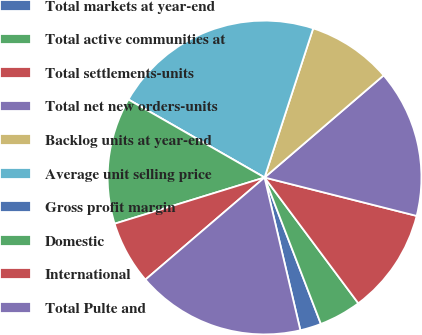<chart> <loc_0><loc_0><loc_500><loc_500><pie_chart><fcel>Total markets at year-end<fcel>Total active communities at<fcel>Total settlements-units<fcel>Total net new orders-units<fcel>Backlog units at year-end<fcel>Average unit selling price<fcel>Gross profit margin<fcel>Domestic<fcel>International<fcel>Total Pulte and<nl><fcel>2.18%<fcel>4.35%<fcel>10.87%<fcel>15.22%<fcel>8.7%<fcel>21.74%<fcel>0.0%<fcel>13.04%<fcel>6.52%<fcel>17.39%<nl></chart> 